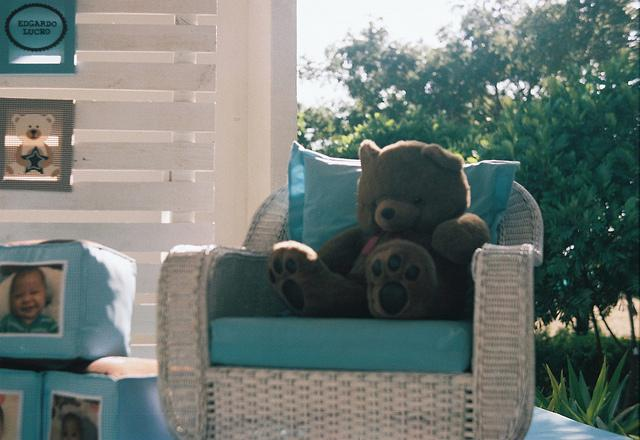How did the bear get there? placed 